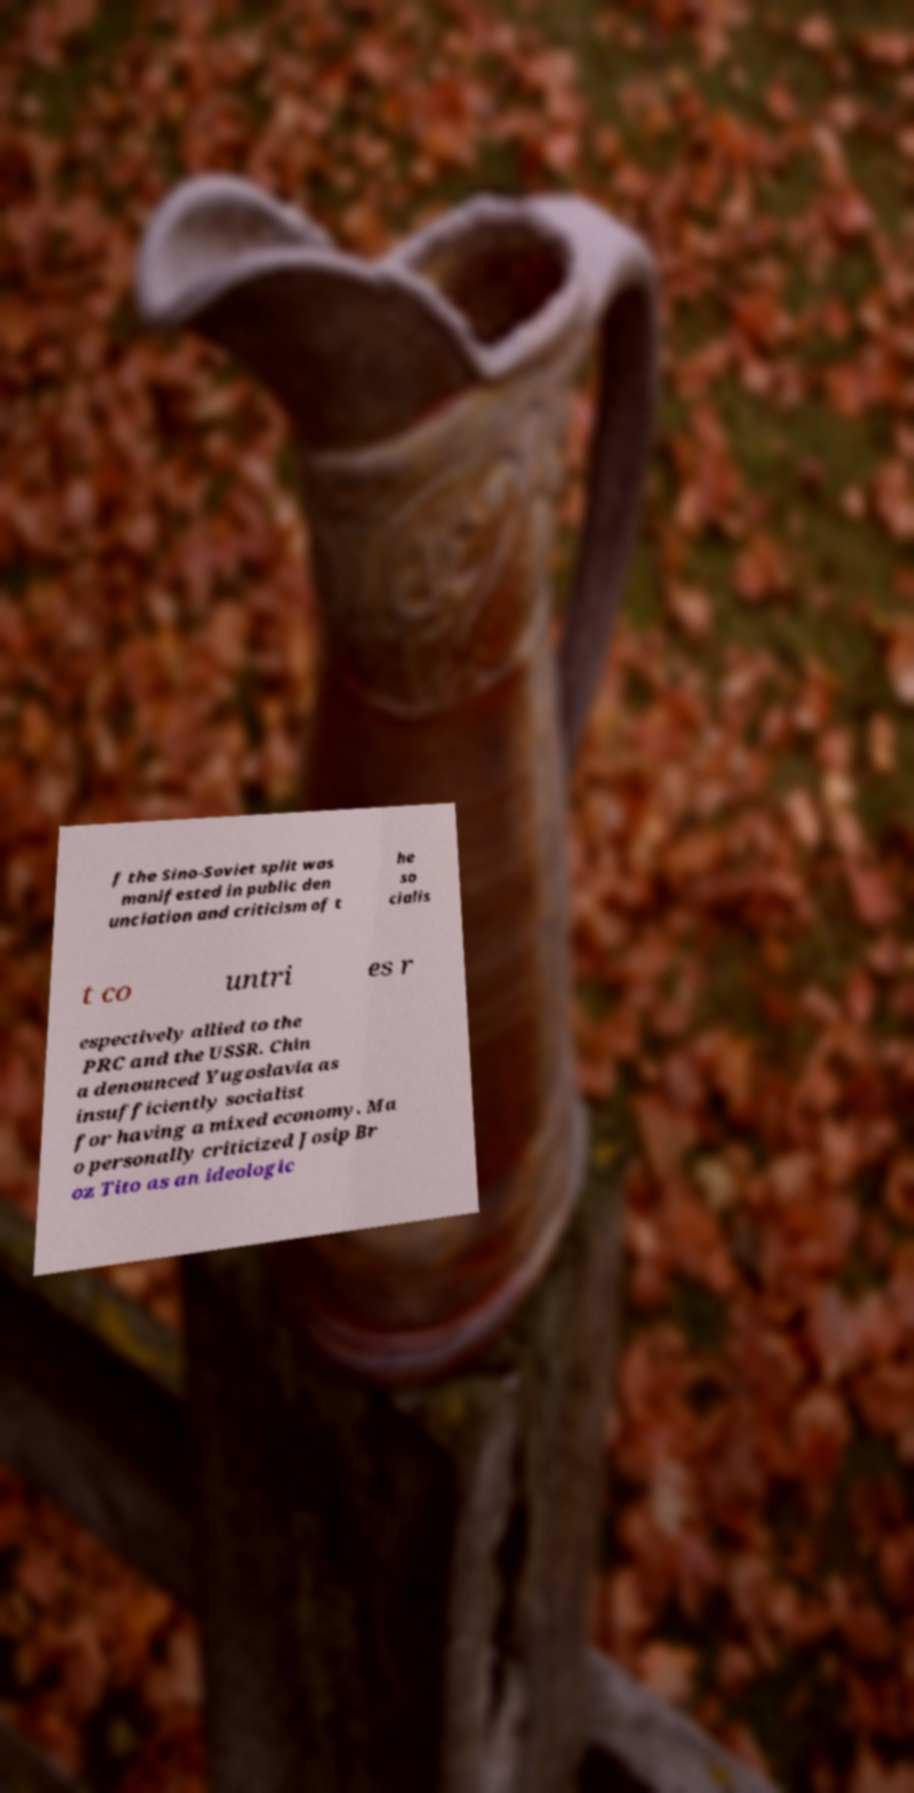Could you extract and type out the text from this image? f the Sino-Soviet split was manifested in public den unciation and criticism of t he so cialis t co untri es r espectively allied to the PRC and the USSR. Chin a denounced Yugoslavia as insufficiently socialist for having a mixed economy. Ma o personally criticized Josip Br oz Tito as an ideologic 